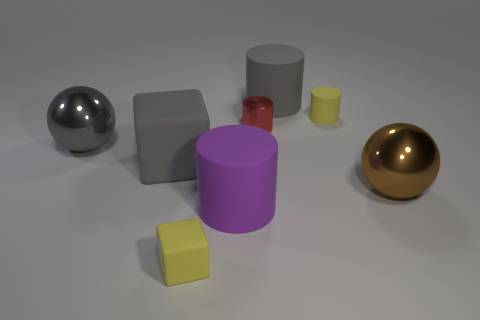Subtract 1 cylinders. How many cylinders are left? 3 Add 2 tiny gray cubes. How many objects exist? 10 Subtract all cyan cylinders. Subtract all red spheres. How many cylinders are left? 4 Subtract all blocks. How many objects are left? 6 Subtract 0 cyan cylinders. How many objects are left? 8 Subtract all small yellow matte spheres. Subtract all tiny yellow matte cylinders. How many objects are left? 7 Add 8 yellow matte things. How many yellow matte things are left? 10 Add 3 gray matte spheres. How many gray matte spheres exist? 3 